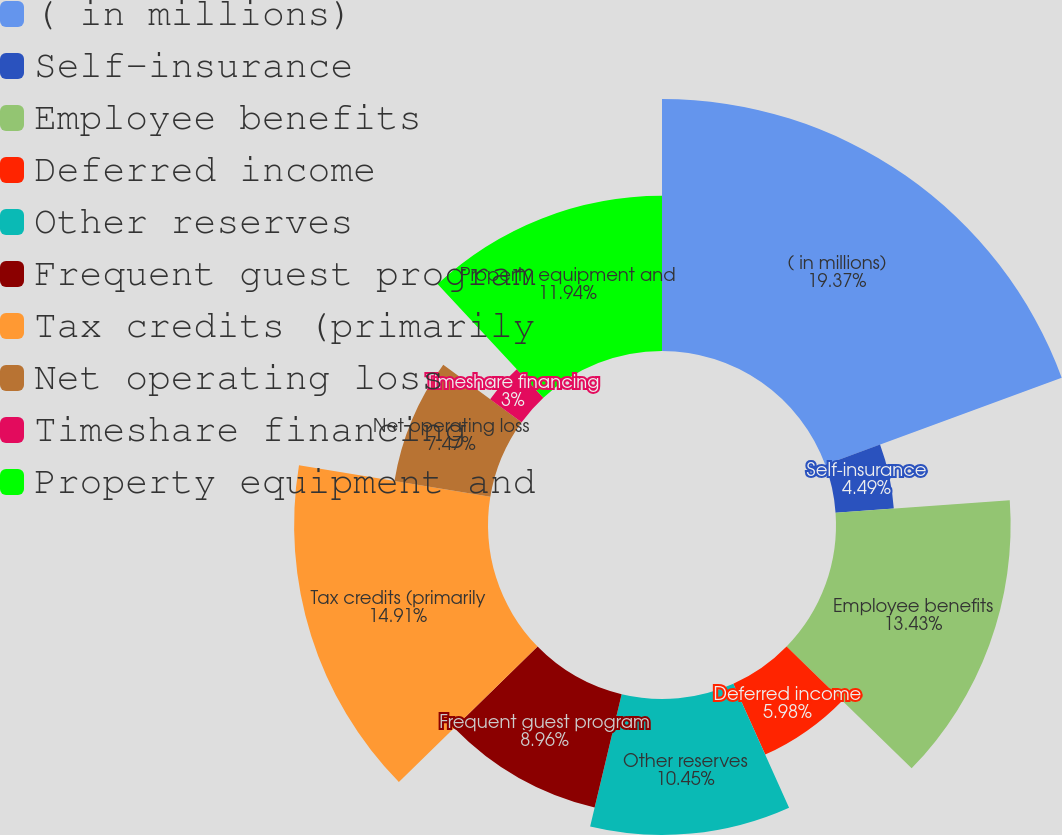Convert chart to OTSL. <chart><loc_0><loc_0><loc_500><loc_500><pie_chart><fcel>( in millions)<fcel>Self-insurance<fcel>Employee benefits<fcel>Deferred income<fcel>Other reserves<fcel>Frequent guest program<fcel>Tax credits (primarily<fcel>Net operating loss<fcel>Timeshare financing<fcel>Property equipment and<nl><fcel>19.38%<fcel>4.49%<fcel>13.43%<fcel>5.98%<fcel>10.45%<fcel>8.96%<fcel>14.91%<fcel>7.47%<fcel>3.0%<fcel>11.94%<nl></chart> 